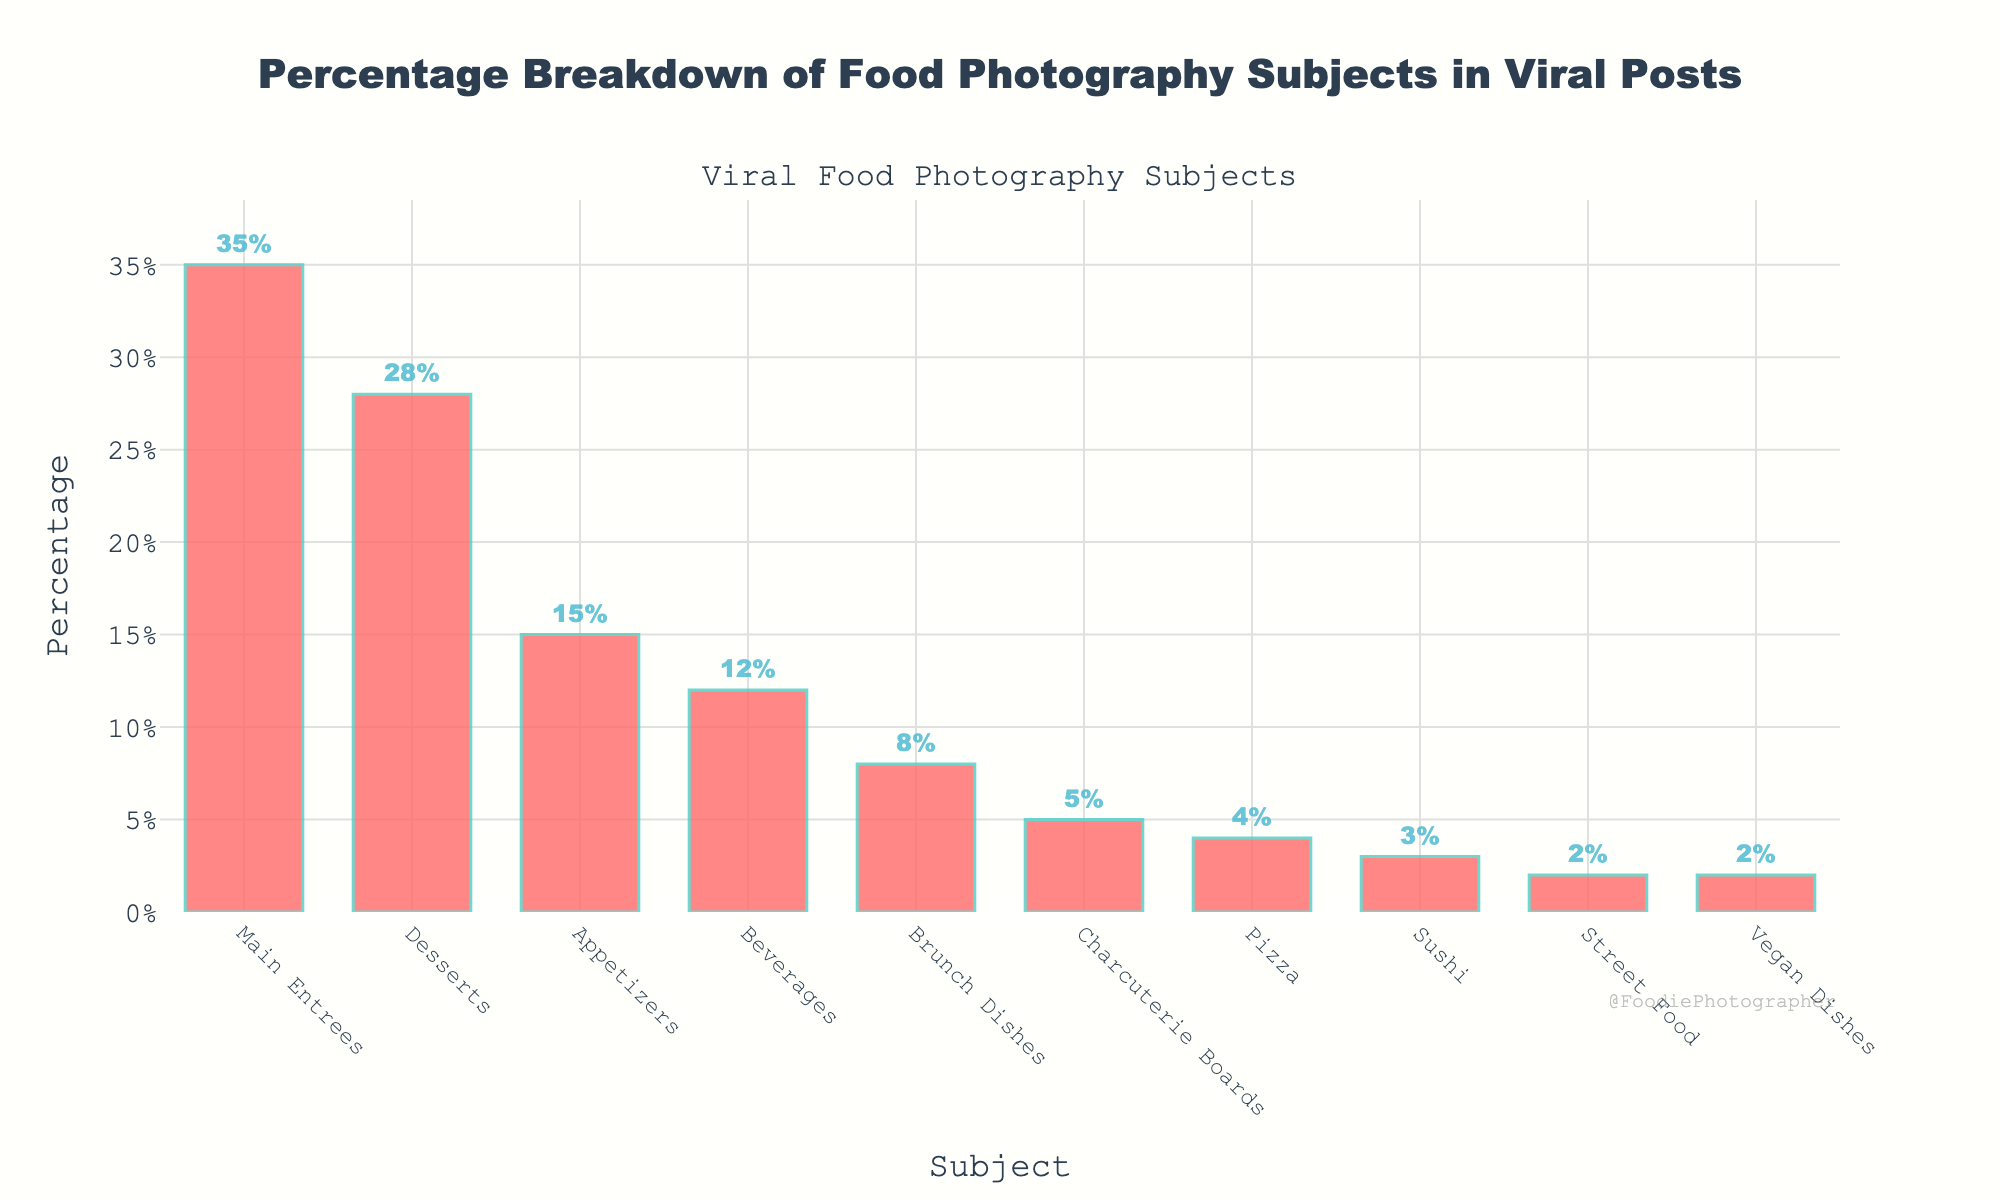What subject is the most popular in viral food photography posts? The bar for "Main Entrees" is the tallest on the chart, indicating it has the highest percentage.
Answer: Main Entrees How much more popular are Main Entrees than Desserts? The percentage for Main Entrees is 35% and for Desserts is 28%. The difference is 35% - 28%.
Answer: 7% Which subjects have a percentage equal to or less than 5%? From the chart, Charcuterie Boards, Pizza, Sushi, Street Food, and Vegan Dishes all have percentages equal to or less than 5%.
Answer: Charcuterie Boards, Pizza, Sushi, Street Food, Vegan Dishes What is the combined percentage for Appetizers and Beverages? Appetizers have 15% and Beverages have 12%. Adding them together is 15% + 12%.
Answer: 27% How many subjects have a percentage greater than 10%? The subjects with percentages greater than 10% are Main Entrees, Desserts, Appetizers, and Beverages, which are four subjects.
Answer: 4 Which subject has the smallest percentage in viral posts? The bar for "Vegan Dishes" is the shortest and has the smallest percentage, which is 2%.
Answer: Vegan Dishes What is the combined percentage of the least popular three subjects? The three least popular subjects are Street Food (2%), Vegan Dishes (2%), and Sushi (3%). Adding them together is 2% + 2% + 3%.
Answer: 7% Which is more popular, Brunch Dishes or Beverages? The percentage for Brunch Dishes is 8%, while Beverages is 12%. Beverages have a higher percentage.
Answer: Beverages Which subject has a percentage closest to 25%? Desserts have a percentage of 28%, which is closest to 25% compared to other subjects.
Answer: Desserts What is the average percentage of Desserts, Appetizers, and Beverages? The total percentage for Desserts (28%), Appetizers (15%), and Beverages (12%) is 28% + 15% + 12% = 55%. The average is 55% / 3.
Answer: 18.33% 